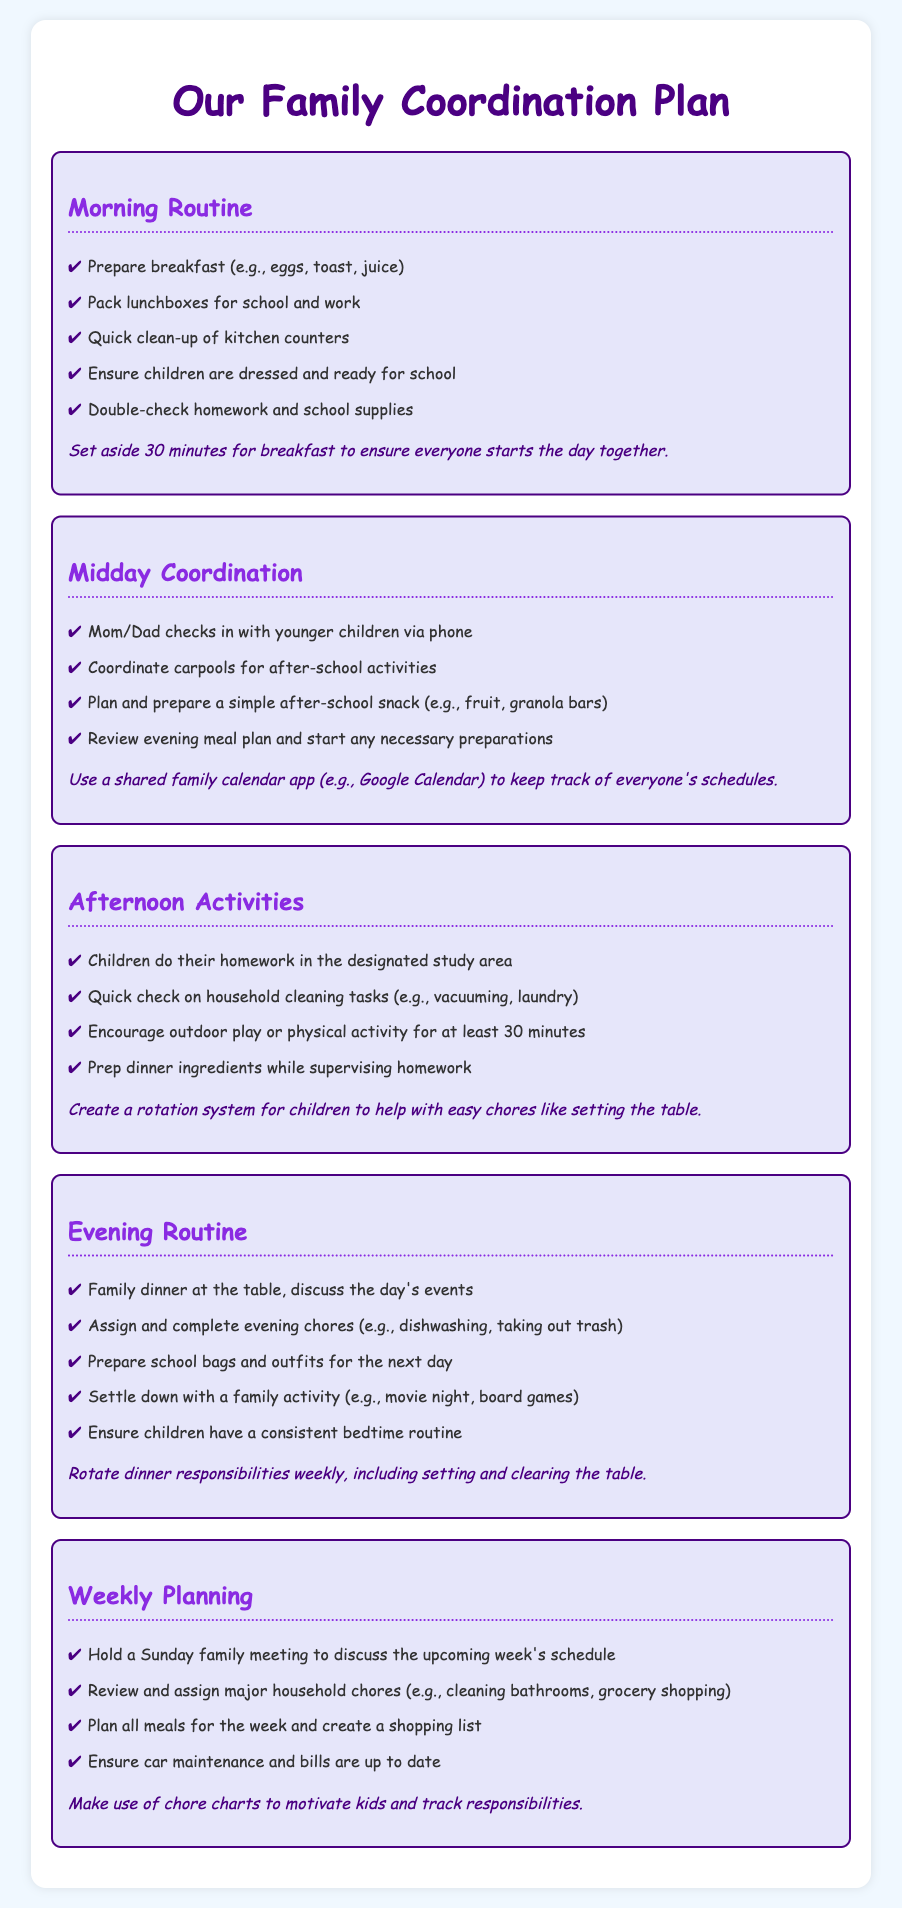What is the title of the document? The title is presented prominently at the top of the document, indicating the focus on family coordination.
Answer: Our Family Coordination Plan How many sections are there in the document? The number of sections can be counted under the main heading, each representing a different part of the family's routine.
Answer: Five What is suggested for breakfast preparation? The document lists specific items to be prepared for breakfast, illustrating what a family might share in their morning routine.
Answer: Eggs, toast, juice What task should children complete in the afternoon? This task is highlighted as important for the children's learning and involvement in family activities.
Answer: Homework When should the family hold a meeting? The schedule for this meeting is set for a specific day of the week to ensure everyone is informed and involved.
Answer: Sunday What type of activity is encouraged for at least 30 minutes? This activity promotes physical well-being and leisure, indicating the importance of playtime for children.
Answer: Outdoor play What is the purpose of a shared family calendar app? The document emphasizes the need for coordination in scheduling, which helps in managing family activities effectively.
Answer: Keep track of everyone's schedules What meal planning action is recommended weekly? This action ensures that the family is organized and prepared for the week ahead in terms of meals and grocery shopping.
Answer: Plan all meals What should be created to motivate kids with chores? This tool is suggested to encourage children to participate in household tasks effectively.
Answer: Chore charts 